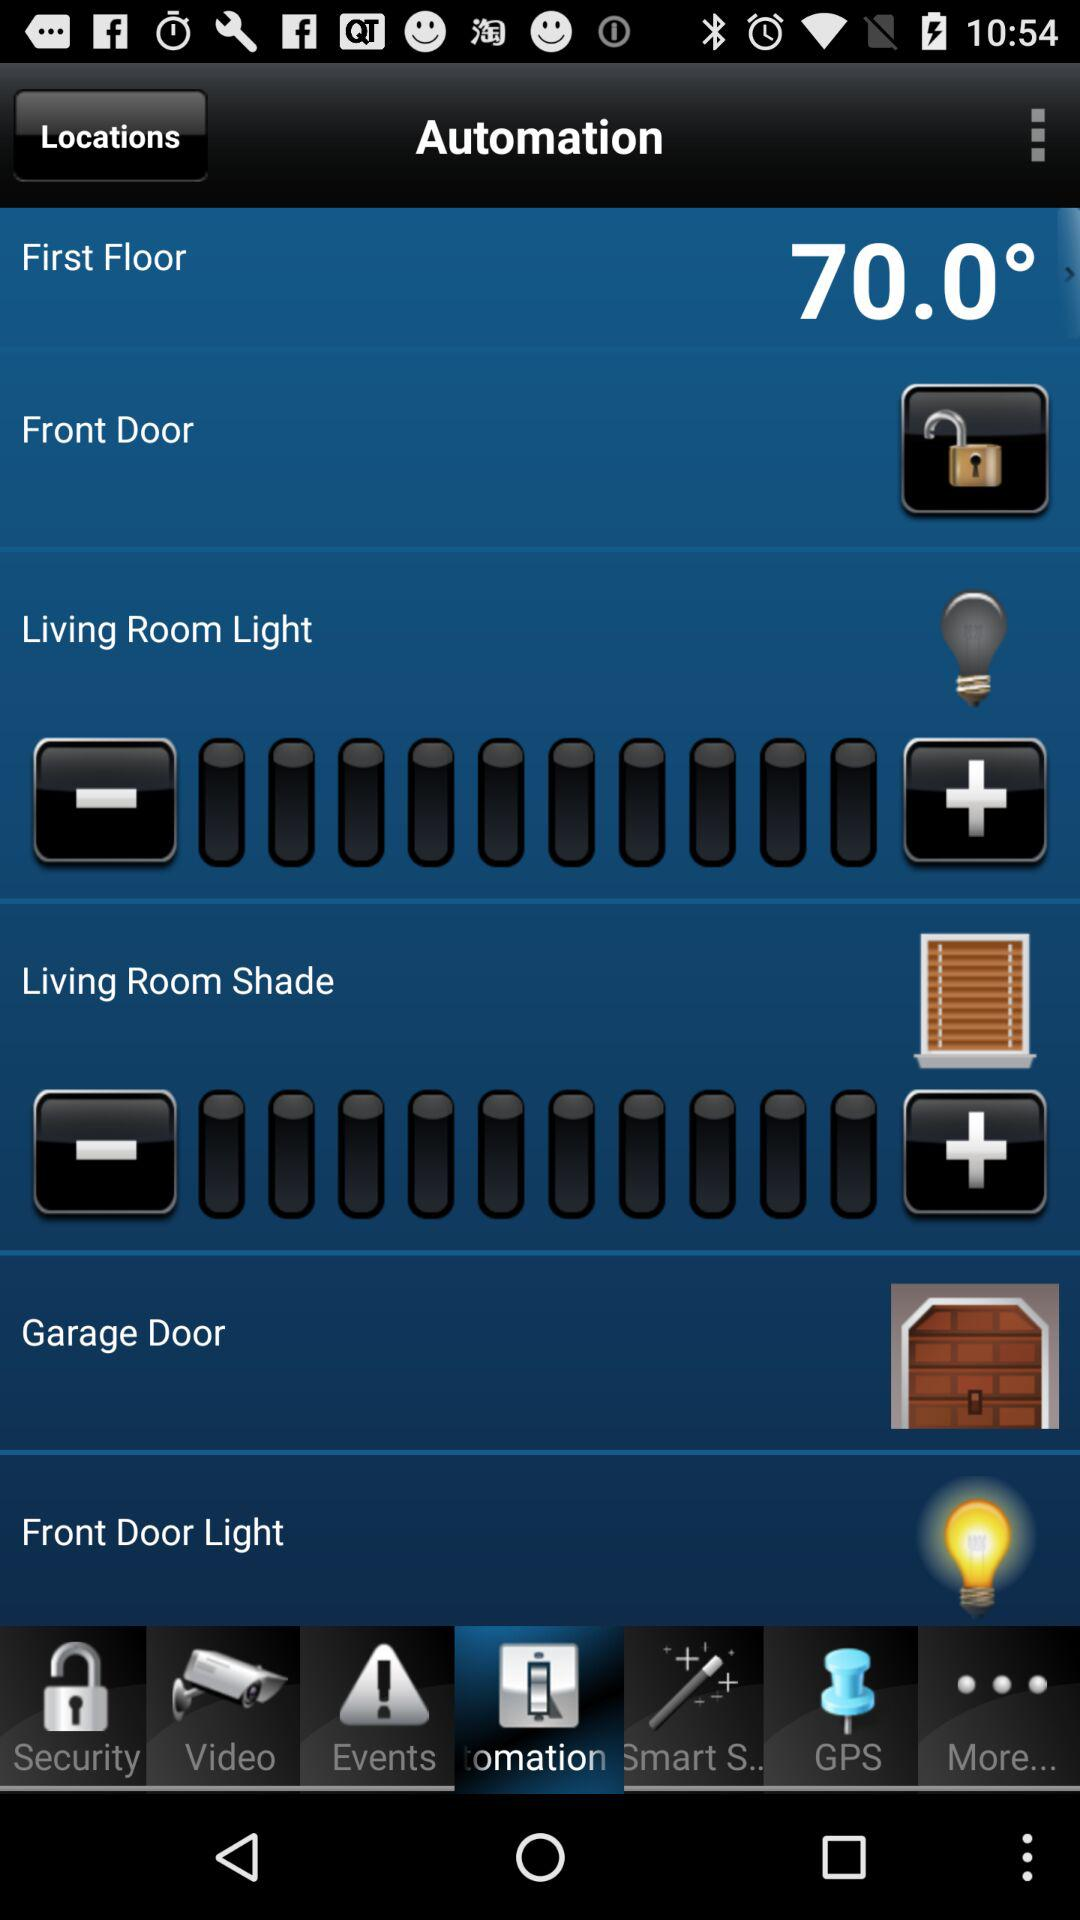Which door lock is open? The lock is open for the front door. 